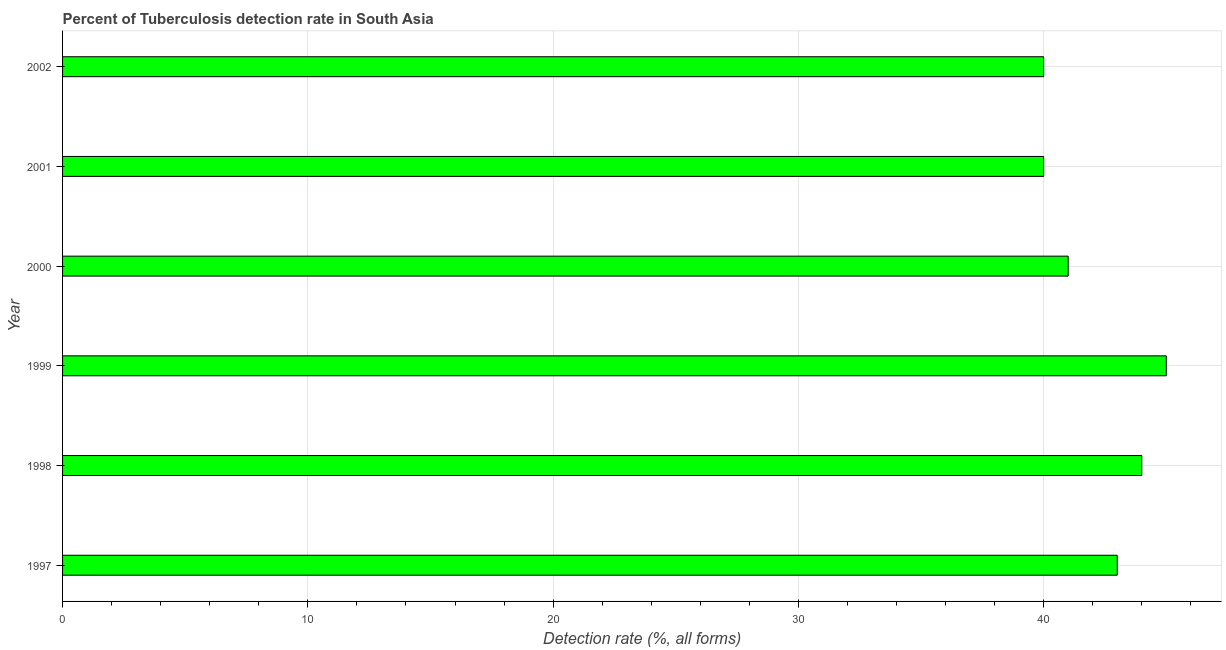Does the graph contain any zero values?
Provide a short and direct response. No. What is the title of the graph?
Offer a very short reply. Percent of Tuberculosis detection rate in South Asia. What is the label or title of the X-axis?
Offer a very short reply. Detection rate (%, all forms). What is the label or title of the Y-axis?
Provide a succinct answer. Year. Across all years, what is the maximum detection rate of tuberculosis?
Your answer should be very brief. 45. In which year was the detection rate of tuberculosis maximum?
Make the answer very short. 1999. What is the sum of the detection rate of tuberculosis?
Ensure brevity in your answer.  253. What is the difference between the detection rate of tuberculosis in 1997 and 2001?
Offer a terse response. 3. What is the average detection rate of tuberculosis per year?
Offer a very short reply. 42. What is the median detection rate of tuberculosis?
Give a very brief answer. 42. In how many years, is the detection rate of tuberculosis greater than 14 %?
Give a very brief answer. 6. Do a majority of the years between 2002 and 1997 (inclusive) have detection rate of tuberculosis greater than 4 %?
Offer a very short reply. Yes. What is the ratio of the detection rate of tuberculosis in 1999 to that in 2002?
Keep it short and to the point. 1.12. Is the detection rate of tuberculosis in 1999 less than that in 2001?
Offer a very short reply. No. What is the difference between the highest and the second highest detection rate of tuberculosis?
Provide a short and direct response. 1. In how many years, is the detection rate of tuberculosis greater than the average detection rate of tuberculosis taken over all years?
Provide a succinct answer. 3. How many bars are there?
Offer a very short reply. 6. Are all the bars in the graph horizontal?
Provide a succinct answer. Yes. What is the difference between two consecutive major ticks on the X-axis?
Your answer should be very brief. 10. Are the values on the major ticks of X-axis written in scientific E-notation?
Ensure brevity in your answer.  No. What is the Detection rate (%, all forms) of 1997?
Keep it short and to the point. 43. What is the Detection rate (%, all forms) of 1999?
Your answer should be compact. 45. What is the Detection rate (%, all forms) of 2001?
Your answer should be compact. 40. What is the Detection rate (%, all forms) of 2002?
Your answer should be very brief. 40. What is the difference between the Detection rate (%, all forms) in 1997 and 1998?
Ensure brevity in your answer.  -1. What is the difference between the Detection rate (%, all forms) in 1998 and 1999?
Offer a terse response. -1. What is the difference between the Detection rate (%, all forms) in 1999 and 2002?
Ensure brevity in your answer.  5. What is the difference between the Detection rate (%, all forms) in 2001 and 2002?
Your response must be concise. 0. What is the ratio of the Detection rate (%, all forms) in 1997 to that in 1999?
Make the answer very short. 0.96. What is the ratio of the Detection rate (%, all forms) in 1997 to that in 2000?
Your answer should be compact. 1.05. What is the ratio of the Detection rate (%, all forms) in 1997 to that in 2001?
Give a very brief answer. 1.07. What is the ratio of the Detection rate (%, all forms) in 1997 to that in 2002?
Your answer should be very brief. 1.07. What is the ratio of the Detection rate (%, all forms) in 1998 to that in 1999?
Provide a succinct answer. 0.98. What is the ratio of the Detection rate (%, all forms) in 1998 to that in 2000?
Make the answer very short. 1.07. What is the ratio of the Detection rate (%, all forms) in 1999 to that in 2000?
Make the answer very short. 1.1. What is the ratio of the Detection rate (%, all forms) in 1999 to that in 2001?
Offer a very short reply. 1.12. What is the ratio of the Detection rate (%, all forms) in 1999 to that in 2002?
Offer a very short reply. 1.12. What is the ratio of the Detection rate (%, all forms) in 2000 to that in 2001?
Keep it short and to the point. 1.02. 